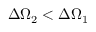Convert formula to latex. <formula><loc_0><loc_0><loc_500><loc_500>\Delta \Omega _ { 2 } < \Delta \Omega _ { 1 }</formula> 